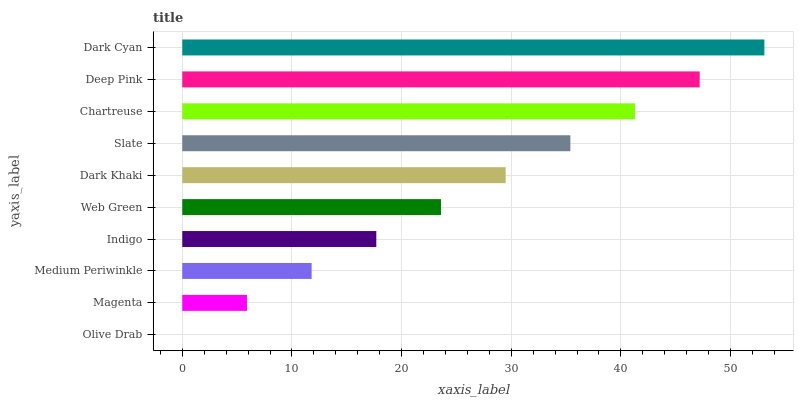Is Olive Drab the minimum?
Answer yes or no. Yes. Is Dark Cyan the maximum?
Answer yes or no. Yes. Is Magenta the minimum?
Answer yes or no. No. Is Magenta the maximum?
Answer yes or no. No. Is Magenta greater than Olive Drab?
Answer yes or no. Yes. Is Olive Drab less than Magenta?
Answer yes or no. Yes. Is Olive Drab greater than Magenta?
Answer yes or no. No. Is Magenta less than Olive Drab?
Answer yes or no. No. Is Dark Khaki the high median?
Answer yes or no. Yes. Is Web Green the low median?
Answer yes or no. Yes. Is Medium Periwinkle the high median?
Answer yes or no. No. Is Indigo the low median?
Answer yes or no. No. 